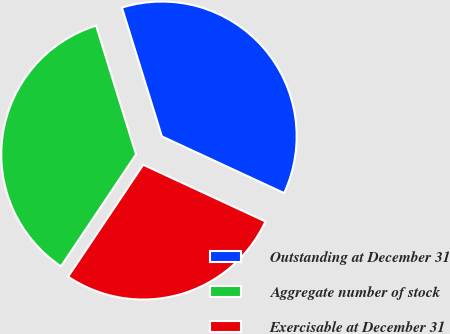<chart> <loc_0><loc_0><loc_500><loc_500><pie_chart><fcel>Outstanding at December 31<fcel>Aggregate number of stock<fcel>Exercisable at December 31<nl><fcel>36.7%<fcel>35.81%<fcel>27.49%<nl></chart> 